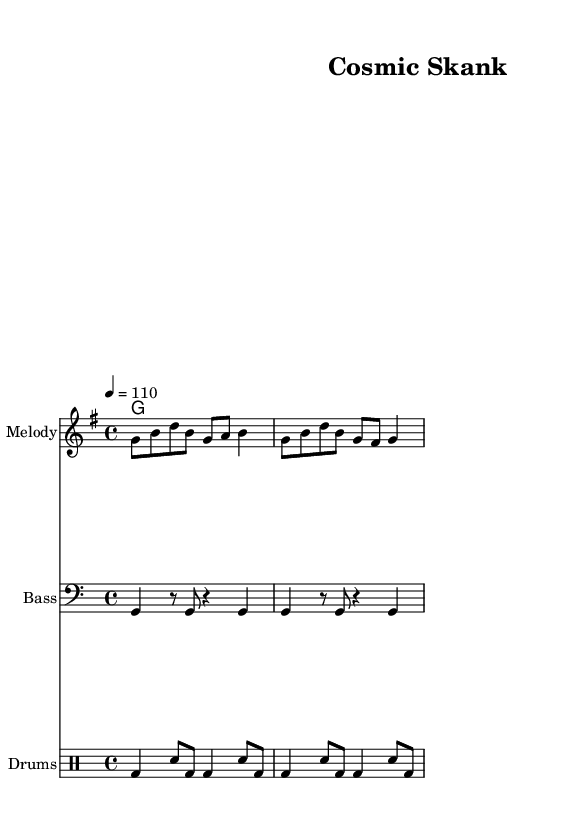What is the key signature of this music? The key signature is G major, which has one sharp (F#). This can be determined by looking at the initial part of the sheet music where the key signature is indicated.
Answer: G major What is the time signature of this piece? The time signature is 4/4, which is indicated at the beginning of the score. This means there are four beats in a measure and a quarter note receives one beat.
Answer: 4/4 What is the tempo marking for this piece? The tempo marking is 110 beats per minute, as stated in the tempo indication at the beginning of the score. This guides how fast the piece should be played.
Answer: 110 How many measures are in the melody part? The melody part contains 4 measures, which can be counted by looking at the number of bar lines in the melody staff. Each section is divided by a vertical line indicating the end of a measure.
Answer: 4 Which instrument is designated for the melody? The instrument designated for the melody is simply labeled "Melody" on the staff at the beginning of the music, indicating that this part is for a melodic instrument, commonly played by a lead player in reggae music.
Answer: Melody What type of rhythm is the drum score primarily using? The drum score is primarily using a bass drum and snare combination, as depicted in the drummode section. This is typical for reggae music, where the bass drum emphasizes the downbeat and the snare provides a backbeat.
Answer: Bass and snare 